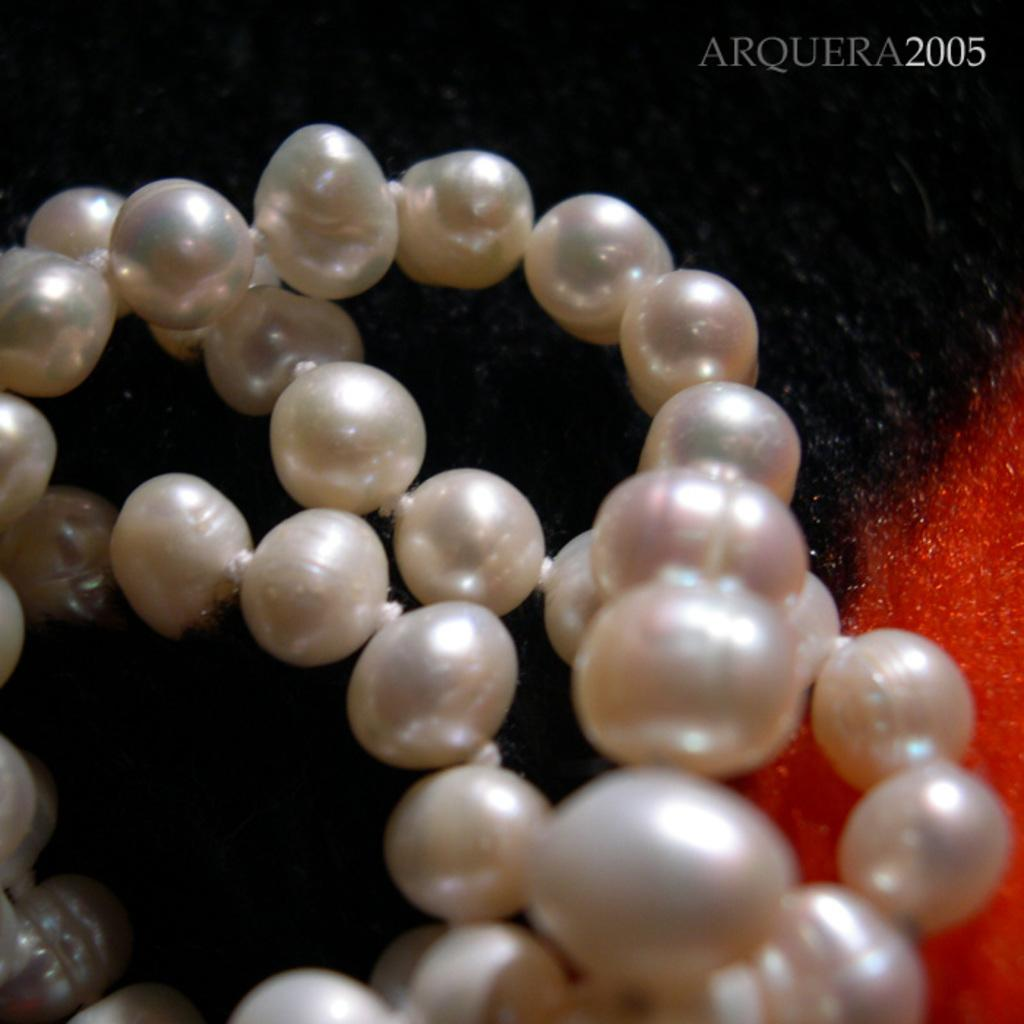What type of objects can be seen in the image? There are pearls in the image. Where are the pearls placed? The pearls are placed on a mat. Can you describe the mat in the image? The mat is black and red in color. What type of lumber is used to make the jar in the image? There is no jar present in the image, so it is not possible to determine the type of lumber used to make it. 